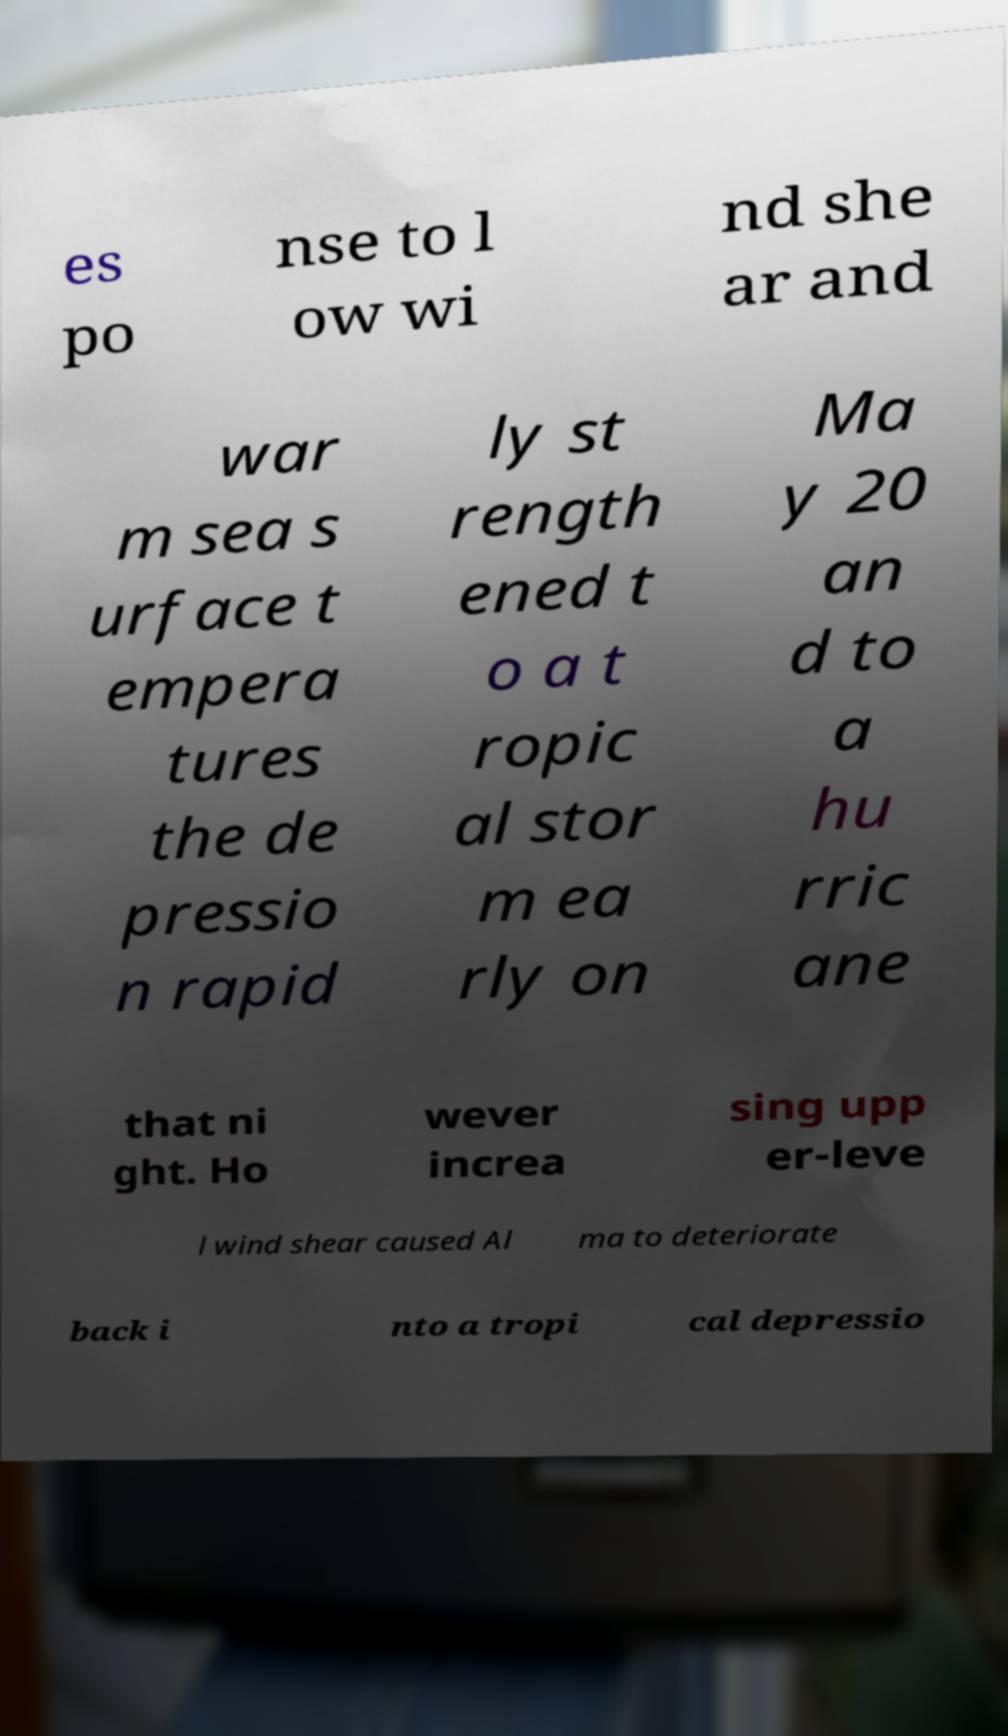Please read and relay the text visible in this image. What does it say? es po nse to l ow wi nd she ar and war m sea s urface t empera tures the de pressio n rapid ly st rength ened t o a t ropic al stor m ea rly on Ma y 20 an d to a hu rric ane that ni ght. Ho wever increa sing upp er-leve l wind shear caused Al ma to deteriorate back i nto a tropi cal depressio 